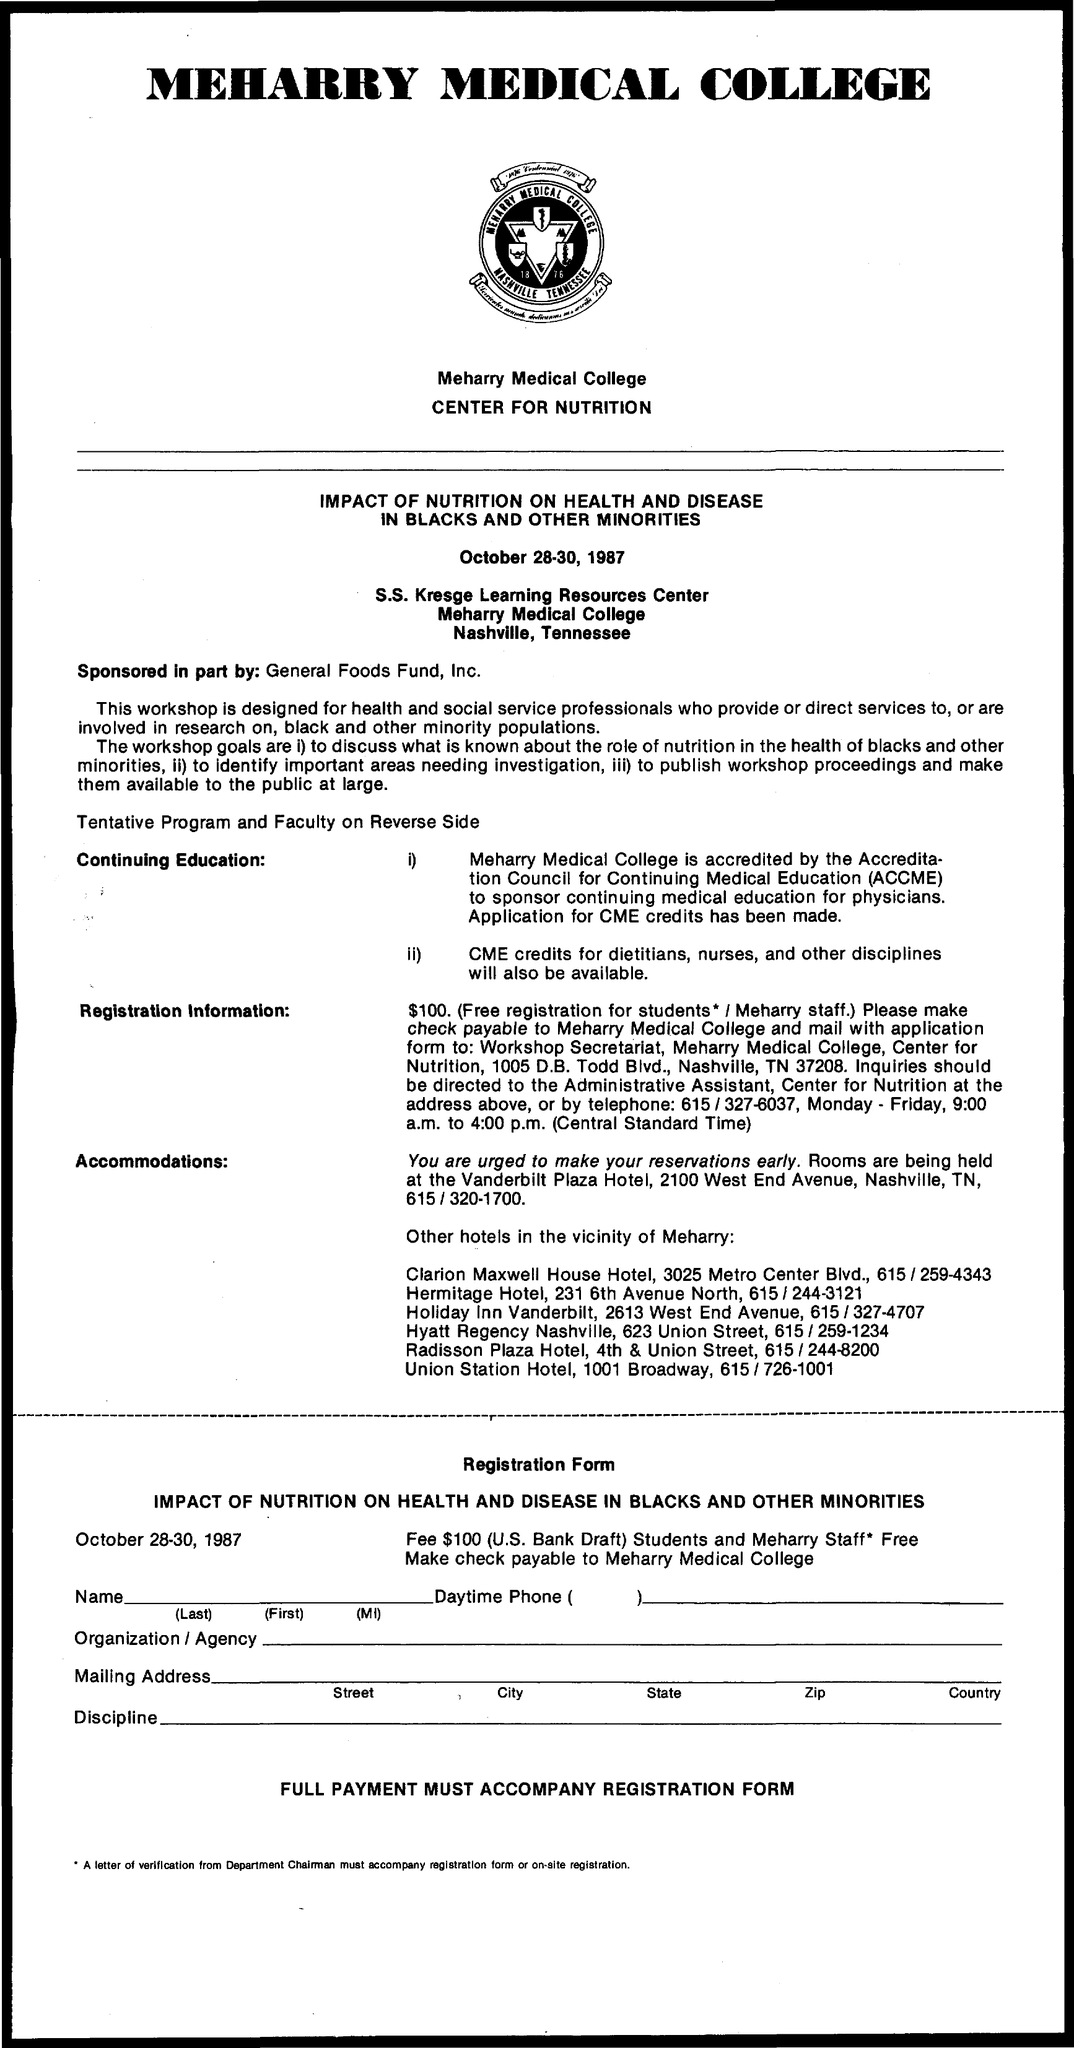Give some essential details in this illustration. I am looking for information on Meharry Medical College. The dates mentioned are October 28-30, 1987. 